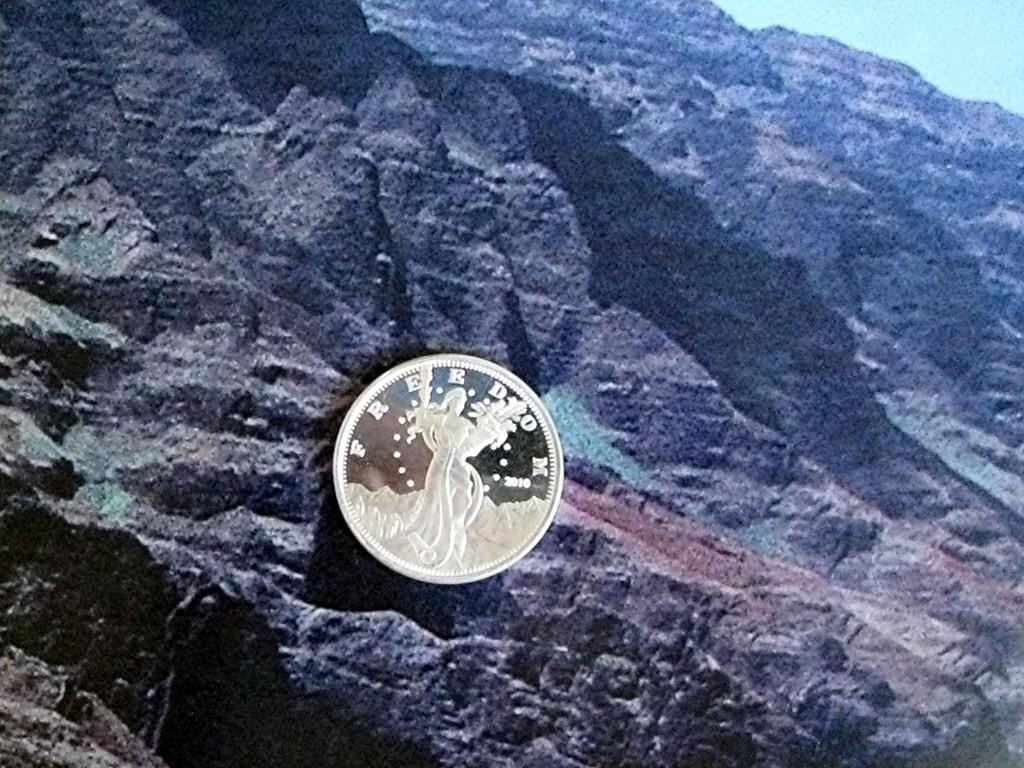What year is written on this coin?
Your response must be concise. 2010. 